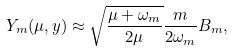<formula> <loc_0><loc_0><loc_500><loc_500>Y _ { m } ( \mu , y ) \approx \sqrt { \frac { \mu + \omega _ { m } } { 2 \mu } } \frac { m } { 2 \omega _ { m } } B _ { m } ,</formula> 